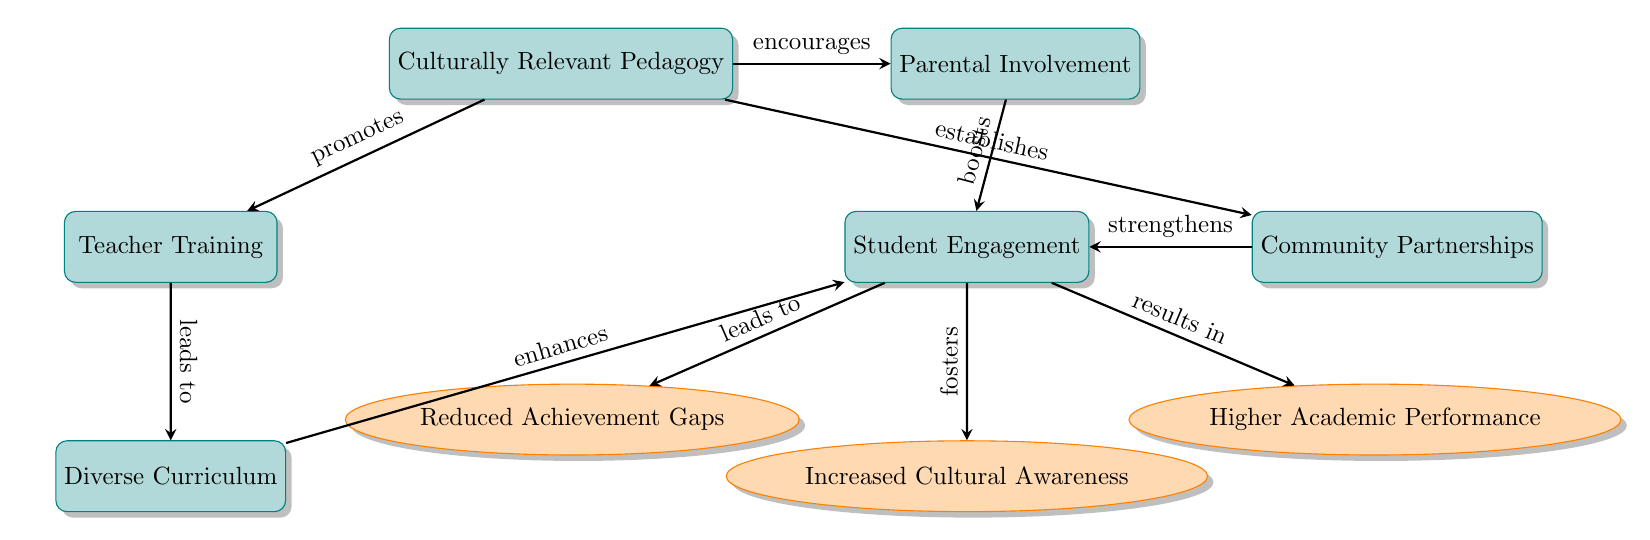What is the main concept illustrated in the diagram? The main concept is located at the top node of the flowchart, which is "Culturally Relevant Pedagogy." This central theme connects to various teaching strategies and their outcomes for diverse classrooms.
Answer: Culturally Relevant Pedagogy How many processes are depicted in the diagram? By counting the rectangular nodes in the diagram, we find there are six processes in total related to culturally relevant pedagogy—teacher training, diverse curriculum, student engagement, parental involvement, and community partnerships.
Answer: 6 What outcome is directly linked to student engagement? The outcome that is directly linked to student engagement, as indicated in the diagram, is "Higher Academic Performance," which shows the effect of increased student engagement.
Answer: Higher Academic Performance Which process establishes community partnerships? According to the diagram, "Culturally Relevant Pedagogy" is identified as the process that establishes community partnerships, shown by the arrow leading to the community partnerships node.
Answer: Culturally Relevant Pedagogy What effect does parental involvement have on student engagement? The diagram shows that parental involvement boosts student engagement according to the arrow connecting these two nodes, indicating a positive relationship between them.
Answer: Boosts What are the two outcomes directly related to student engagement? The diagram indicates that there are two outcomes directly resulting from student engagement: "Reduced Achievement Gaps" and "Increased Cultural Awareness," emphasizing the benefits of engaging students effectively.
Answer: Reduced Achievement Gaps, Increased Cultural Awareness How does teacher training relate to diverse curriculum? The arrow connecting "Teacher Training" to "Diverse Curriculum" in the diagram suggests that teacher training leads to the development or enhancement of a diverse curriculum, reflecting a causal relationship.
Answer: Leads to What is the common goal of all depicted processes? The common goal reflected by all the processes in the diagram is to improve student participation and success in diverse classrooms, as indicated by their connection to student engagement and the resulting outcomes.
Answer: Improve student participation and success 